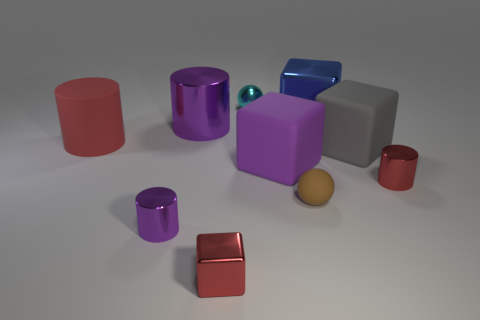The small rubber sphere has what color?
Your answer should be very brief. Brown. What number of other things are the same size as the cyan metal ball?
Your answer should be very brief. 4. There is a tiny cyan sphere right of the big purple object that is behind the large red object; what is its material?
Offer a terse response. Metal. There is a blue metallic thing; is it the same size as the sphere in front of the red rubber cylinder?
Offer a terse response. No. Are there any other metal spheres that have the same color as the tiny metal ball?
Provide a short and direct response. No. What number of tiny objects are purple things or cylinders?
Provide a succinct answer. 2. What number of red matte blocks are there?
Keep it short and to the point. 0. There is a red object that is behind the big gray block; what is its material?
Offer a very short reply. Rubber. Are there any shiny blocks behind the blue metallic thing?
Ensure brevity in your answer.  No. Is the rubber cylinder the same size as the rubber sphere?
Offer a very short reply. No. 